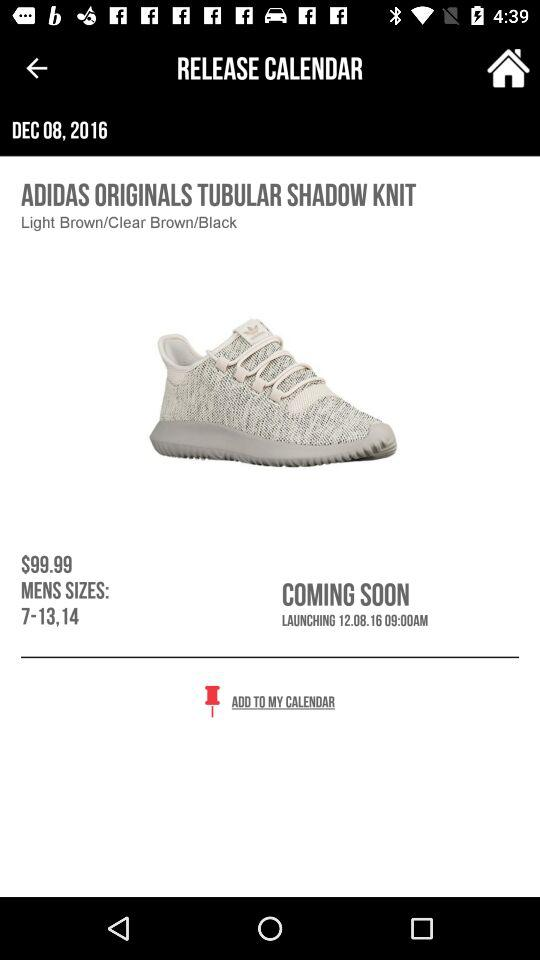How many sizes are available for the adidas tubular shadow knit?
Answer the question using a single word or phrase. 7-13,14 